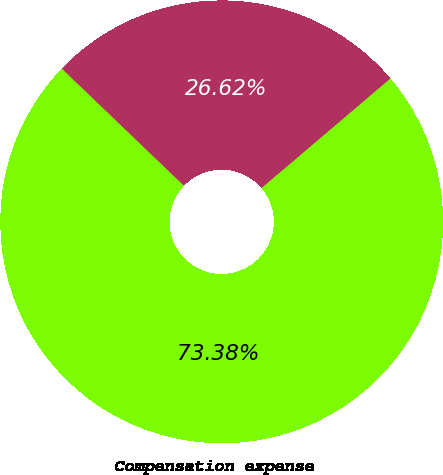<chart> <loc_0><loc_0><loc_500><loc_500><pie_chart><fcel>Compensation expense<fcel>Future income tax benefit<nl><fcel>73.38%<fcel>26.62%<nl></chart> 